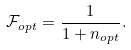Convert formula to latex. <formula><loc_0><loc_0><loc_500><loc_500>\mathcal { F } _ { o p t } = \frac { 1 } { 1 + n _ { o p t } } .</formula> 